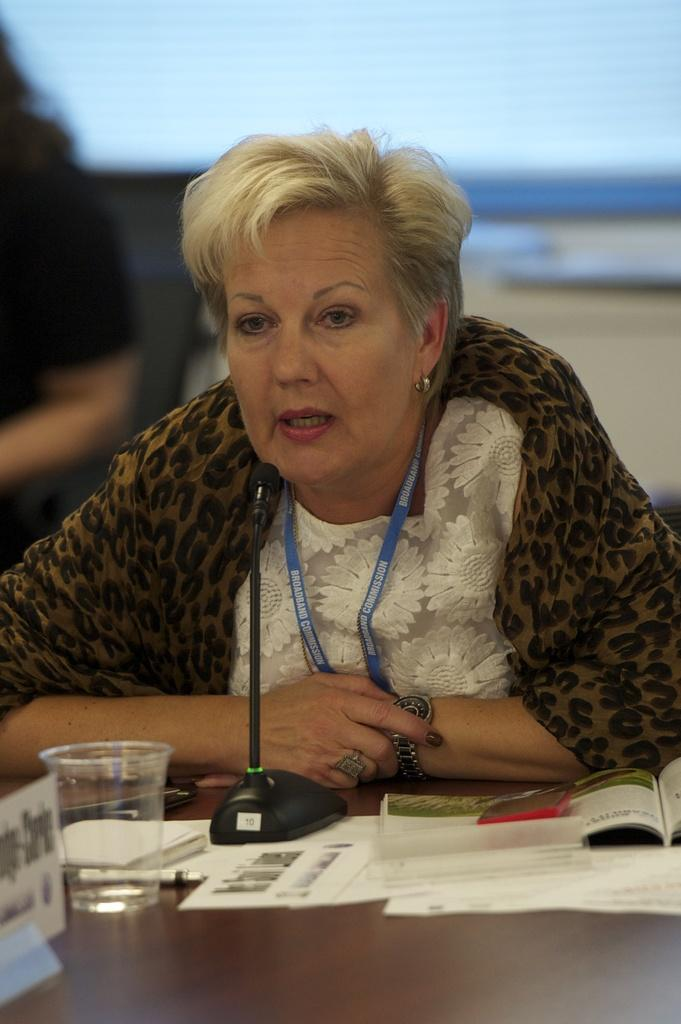Who is the main subject in the image? There is a woman in the image. What is the woman doing in the image? The woman is seated and speaking with the help of a microphone. What objects are on the table in the image? There are papers and a glass on the table. How many planes can be seen flying in the image? There are no planes visible in the image. Are there any chickens present in the image? There are no chickens present in the image. 